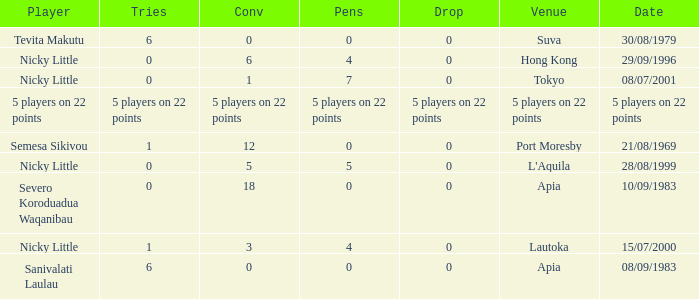How many drops did Nicky Little have in Hong Kong? 0.0. I'm looking to parse the entire table for insights. Could you assist me with that? {'header': ['Player', 'Tries', 'Conv', 'Pens', 'Drop', 'Venue', 'Date'], 'rows': [['Tevita Makutu', '6', '0', '0', '0', 'Suva', '30/08/1979'], ['Nicky Little', '0', '6', '4', '0', 'Hong Kong', '29/09/1996'], ['Nicky Little', '0', '1', '7', '0', 'Tokyo', '08/07/2001'], ['5 players on 22 points', '5 players on 22 points', '5 players on 22 points', '5 players on 22 points', '5 players on 22 points', '5 players on 22 points', '5 players on 22 points'], ['Semesa Sikivou', '1', '12', '0', '0', 'Port Moresby', '21/08/1969'], ['Nicky Little', '0', '5', '5', '0', "L'Aquila", '28/08/1999'], ['Severo Koroduadua Waqanibau', '0', '18', '0', '0', 'Apia', '10/09/1983'], ['Nicky Little', '1', '3', '4', '0', 'Lautoka', '15/07/2000'], ['Sanivalati Laulau', '6', '0', '0', '0', 'Apia', '08/09/1983']]} 